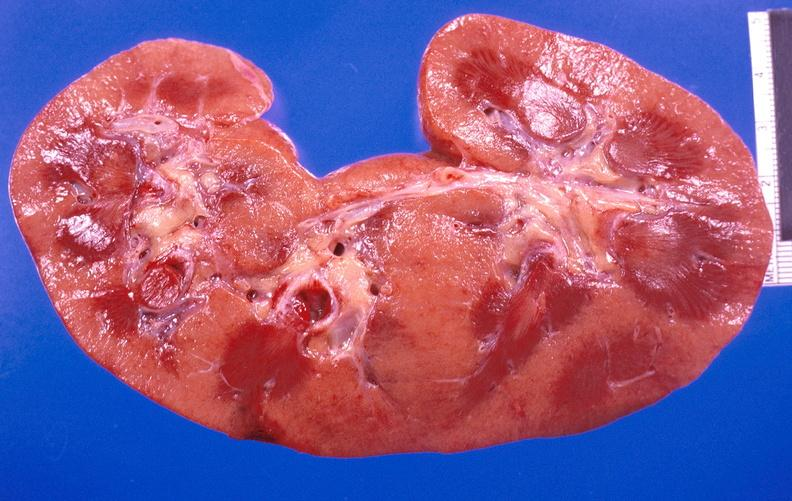does metastatic carcinoma breast show kidney aspergillosis?
Answer the question using a single word or phrase. No 